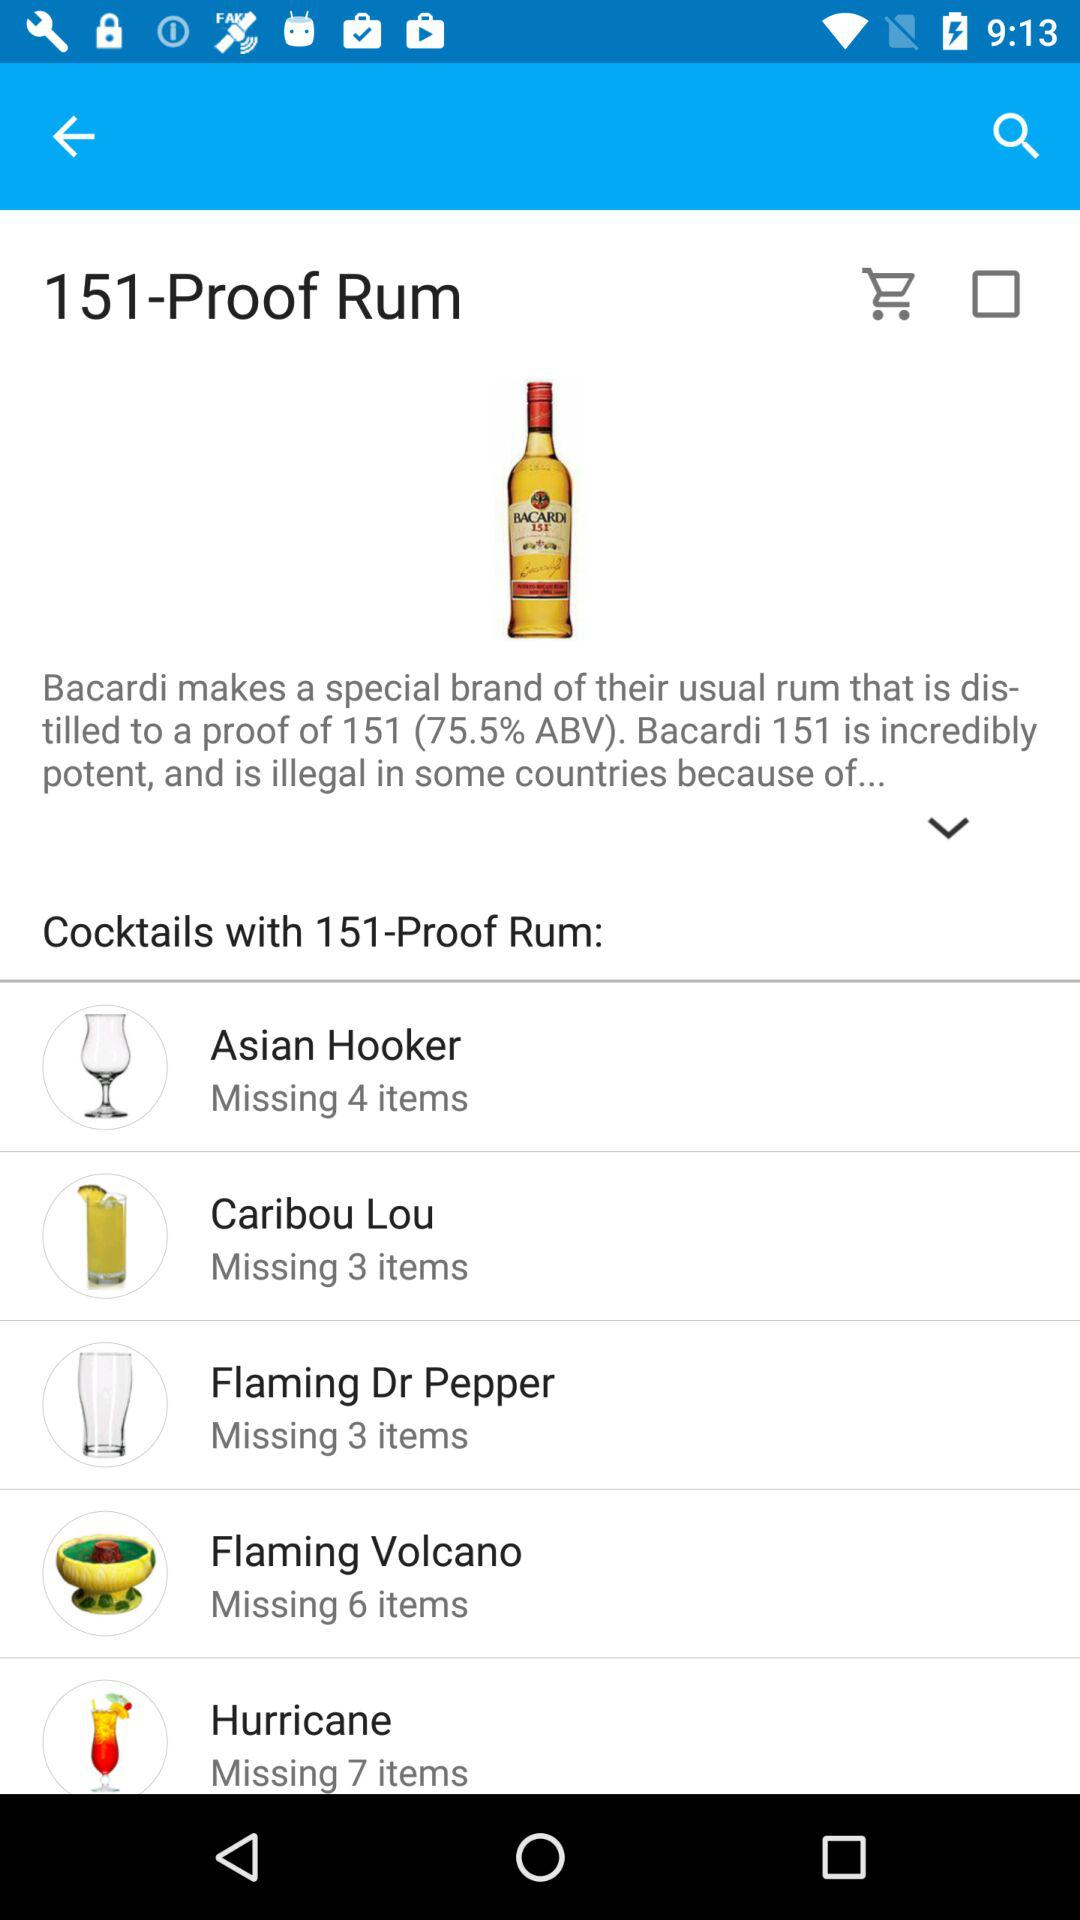Which cocktail is missing six items? The cocktail that is missing six items is "Flaming Volcano". 